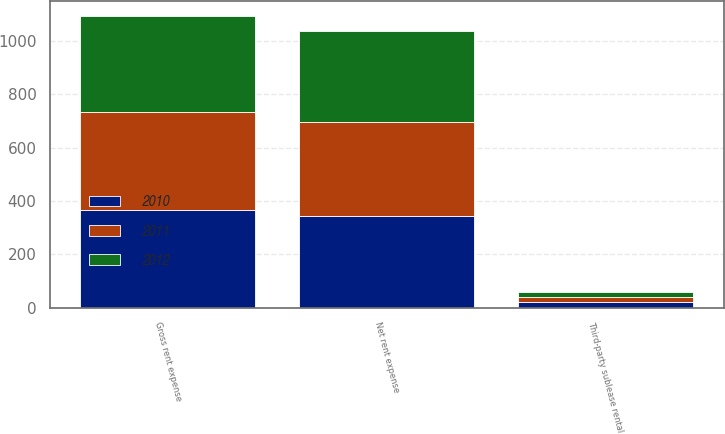Convert chart to OTSL. <chart><loc_0><loc_0><loc_500><loc_500><stacked_bar_chart><ecel><fcel>Gross rent expense<fcel>Third-party sublease rental<fcel>Net rent expense<nl><fcel>2012<fcel>358.5<fcel>17.5<fcel>341<nl><fcel>2011<fcel>369.5<fcel>19.4<fcel>350.1<nl><fcel>2010<fcel>365.2<fcel>20<fcel>345.2<nl></chart> 